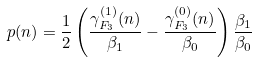Convert formula to latex. <formula><loc_0><loc_0><loc_500><loc_500>p ( n ) = \frac { 1 } { 2 } \left ( \frac { \gamma _ { F _ { 3 } } ^ { ( 1 ) } ( n ) } { \beta _ { 1 } } - \frac { \gamma _ { F _ { 3 } } ^ { ( 0 ) } ( n ) } { \beta _ { 0 } } \right ) \frac { \beta _ { 1 } } { \beta _ { 0 } }</formula> 